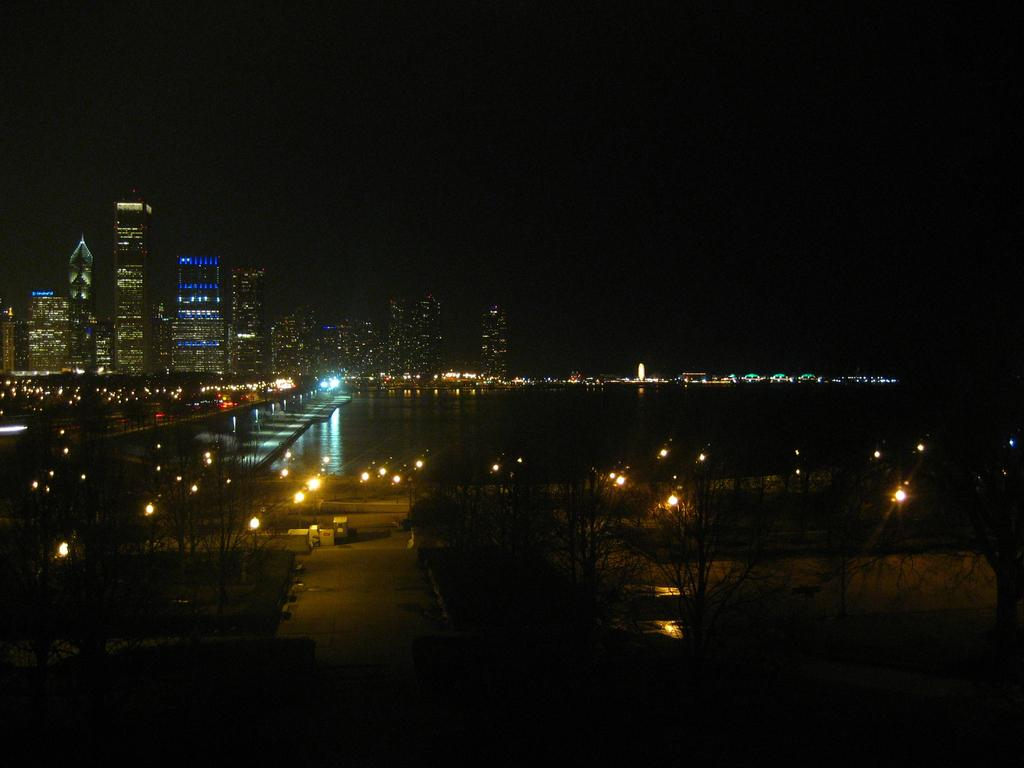What type of natural elements can be seen in the image? There are trees visible in the image. What type of man-made structures can be seen in the image? There are light poles, a bridge, houses, buildings, and towers visible in the image. What type of water feature can be seen in the image? There is water visible in the image. What part of the natural environment is visible in the image? The sky is visible in the image. Can you describe the time of day the image may have been taken? The image may have been taken during the night, as indicated by the presence of light poles and the absence of sunlight. Can you tell me how many lawyers are visible in the image? There are no lawyers present in the image. What type of cat can be seen playing with the water in the image? There is no cat present in the image, and therefore no such activity can be observed. 